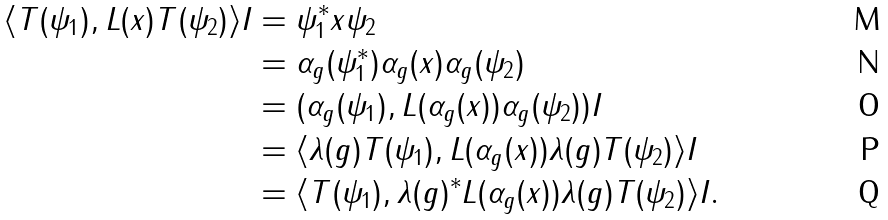Convert formula to latex. <formula><loc_0><loc_0><loc_500><loc_500>\langle T ( \psi _ { 1 } ) , L ( x ) T ( \psi _ { 2 } ) \rangle I & = \psi _ { 1 } ^ { * } x \psi _ { 2 } \\ & = \alpha _ { g } ( \psi _ { 1 } ^ { * } ) \alpha _ { g } ( x ) \alpha _ { g } ( \psi _ { 2 } ) \\ & = ( \alpha _ { g } ( \psi _ { 1 } ) , L ( \alpha _ { g } ( x ) ) \alpha _ { g } ( \psi _ { 2 } ) ) I \\ & = \langle \lambda ( g ) T ( \psi _ { 1 } ) , L ( \alpha _ { g } ( x ) ) \lambda ( g ) T ( \psi _ { 2 } ) \rangle I \\ & = \langle T ( \psi _ { 1 } ) , \lambda ( g ) ^ { * } L ( \alpha _ { g } ( x ) ) \lambda ( g ) T ( \psi _ { 2 } ) \rangle I .</formula> 